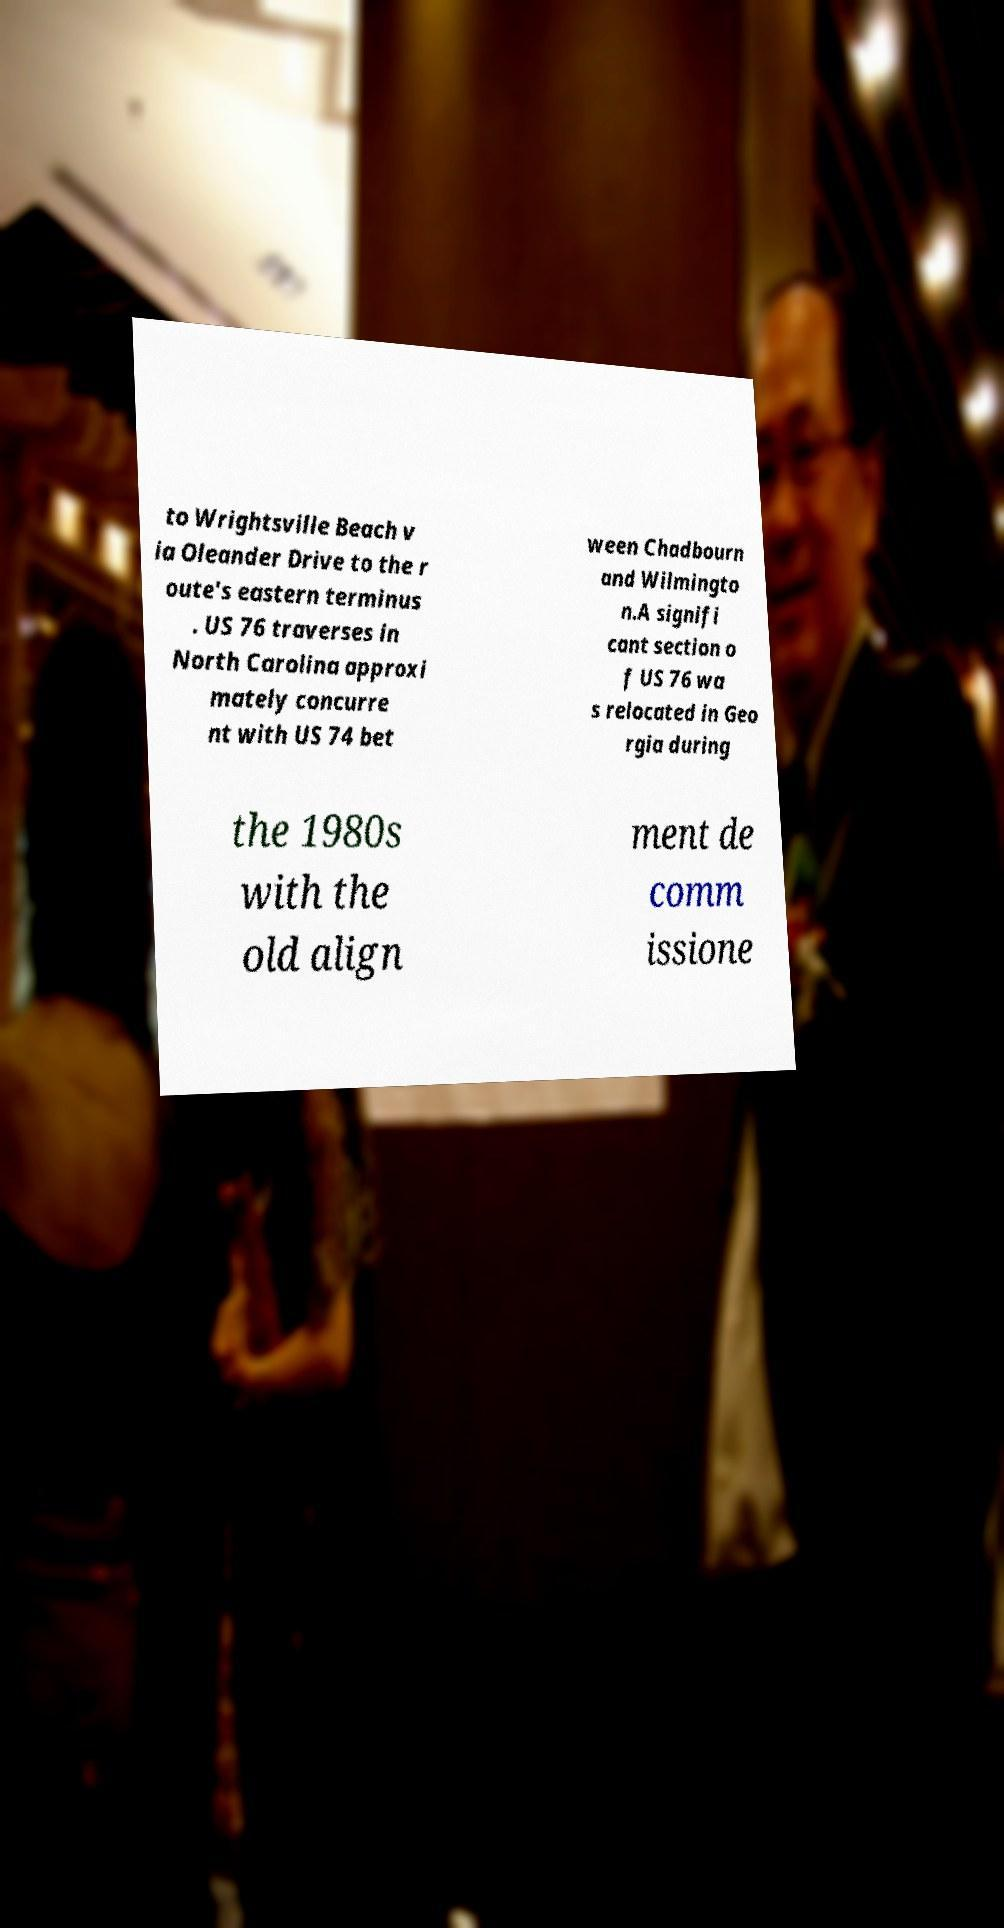There's text embedded in this image that I need extracted. Can you transcribe it verbatim? to Wrightsville Beach v ia Oleander Drive to the r oute's eastern terminus . US 76 traverses in North Carolina approxi mately concurre nt with US 74 bet ween Chadbourn and Wilmingto n.A signifi cant section o f US 76 wa s relocated in Geo rgia during the 1980s with the old align ment de comm issione 